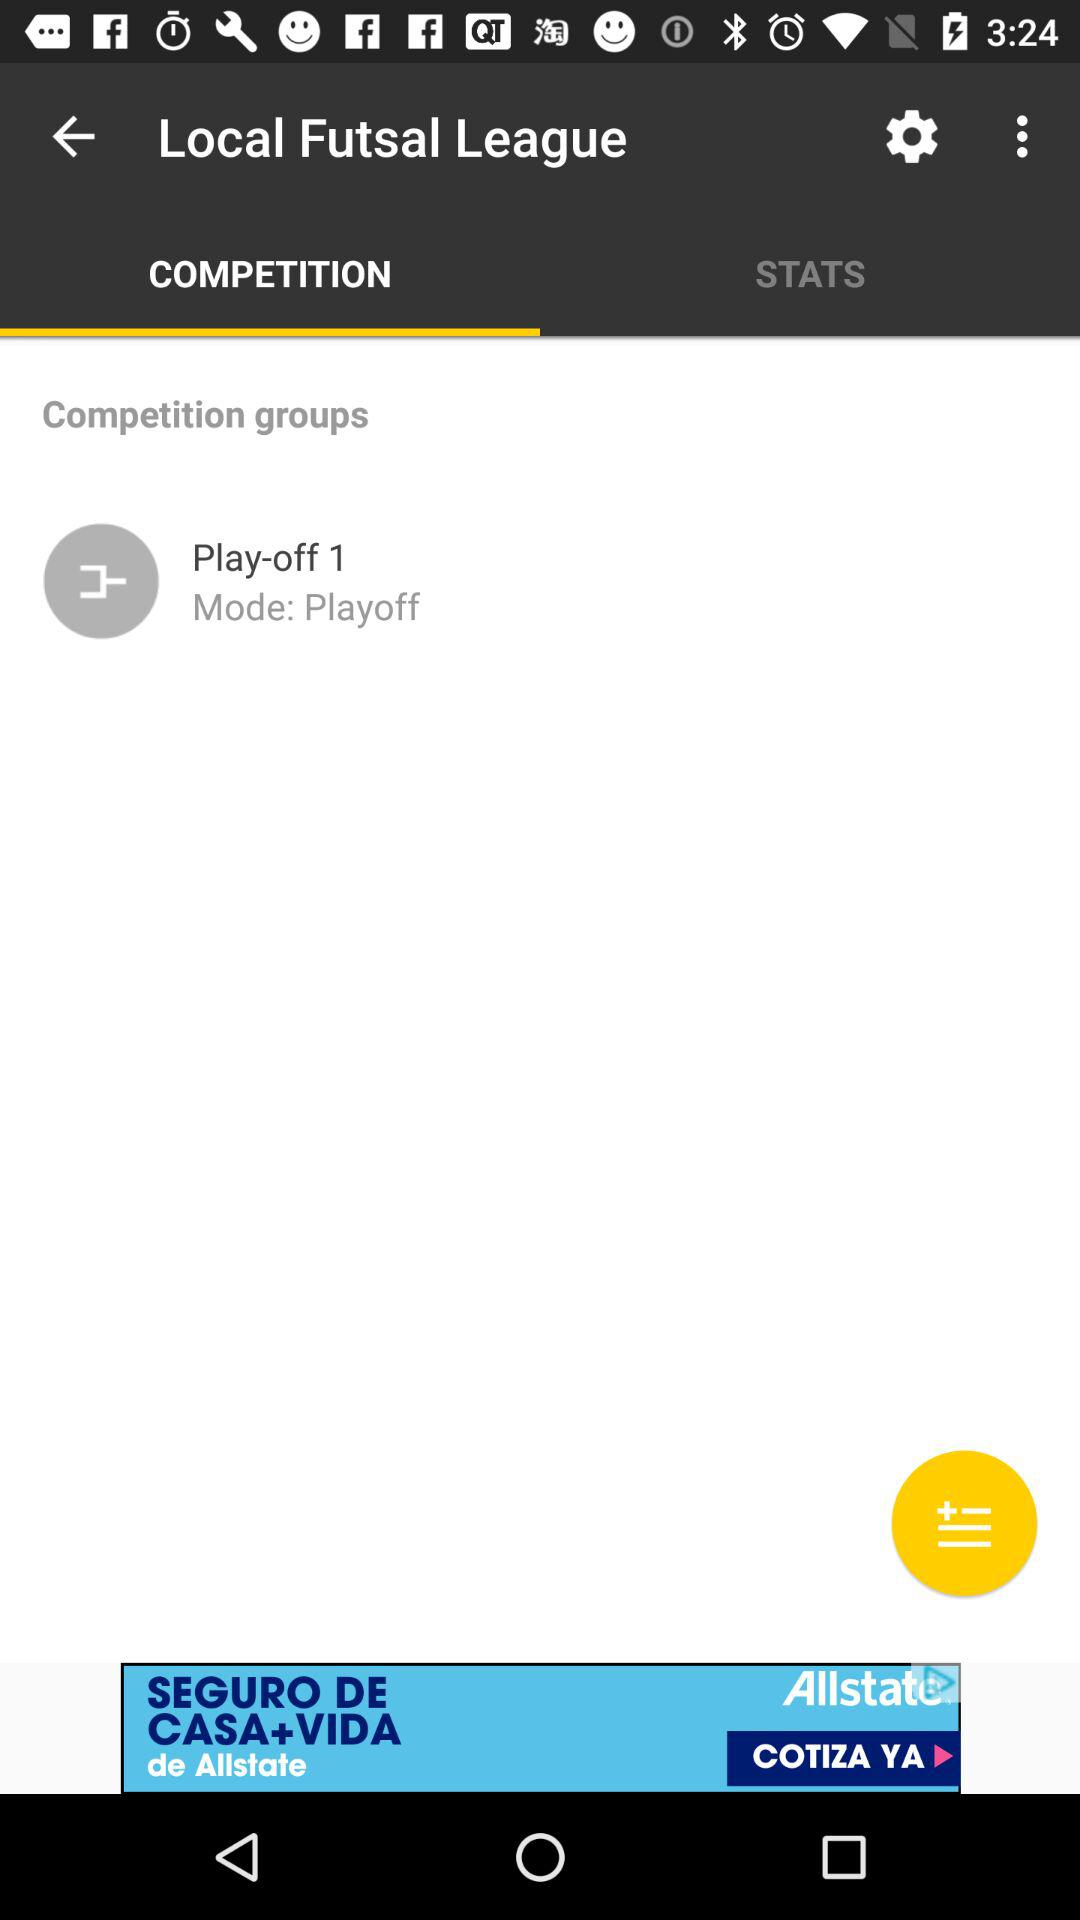What is the mode of "Play-off 1"? The mode is "Playoff". 